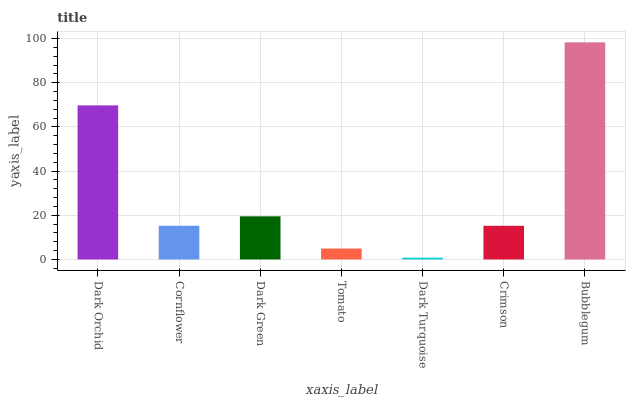Is Dark Turquoise the minimum?
Answer yes or no. Yes. Is Bubblegum the maximum?
Answer yes or no. Yes. Is Cornflower the minimum?
Answer yes or no. No. Is Cornflower the maximum?
Answer yes or no. No. Is Dark Orchid greater than Cornflower?
Answer yes or no. Yes. Is Cornflower less than Dark Orchid?
Answer yes or no. Yes. Is Cornflower greater than Dark Orchid?
Answer yes or no. No. Is Dark Orchid less than Cornflower?
Answer yes or no. No. Is Cornflower the high median?
Answer yes or no. Yes. Is Cornflower the low median?
Answer yes or no. Yes. Is Bubblegum the high median?
Answer yes or no. No. Is Dark Green the low median?
Answer yes or no. No. 